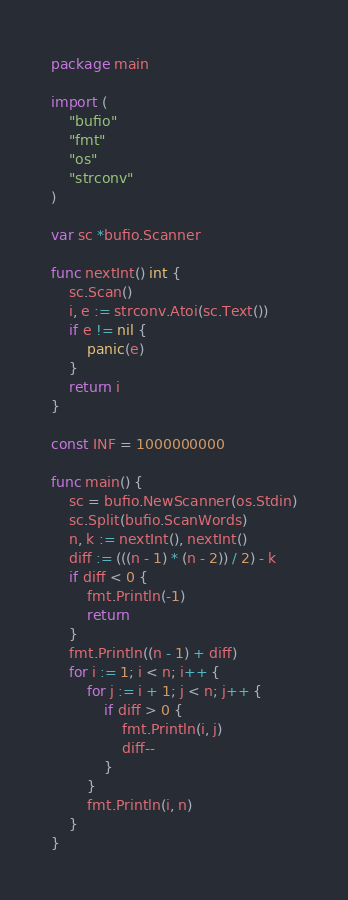<code> <loc_0><loc_0><loc_500><loc_500><_Go_>package main

import (
	"bufio"
	"fmt"
	"os"
	"strconv"
)

var sc *bufio.Scanner

func nextInt() int {
	sc.Scan()
	i, e := strconv.Atoi(sc.Text())
	if e != nil {
		panic(e)
	}
	return i
}

const INF = 1000000000

func main() {
	sc = bufio.NewScanner(os.Stdin)
	sc.Split(bufio.ScanWords)
	n, k := nextInt(), nextInt()
	diff := (((n - 1) * (n - 2)) / 2) - k
	if diff < 0 {
		fmt.Println(-1)
		return
	}
	fmt.Println((n - 1) + diff)
	for i := 1; i < n; i++ {
		for j := i + 1; j < n; j++ {
			if diff > 0 {
				fmt.Println(i, j)
				diff--
			}
		}
		fmt.Println(i, n)
	}
}
</code> 